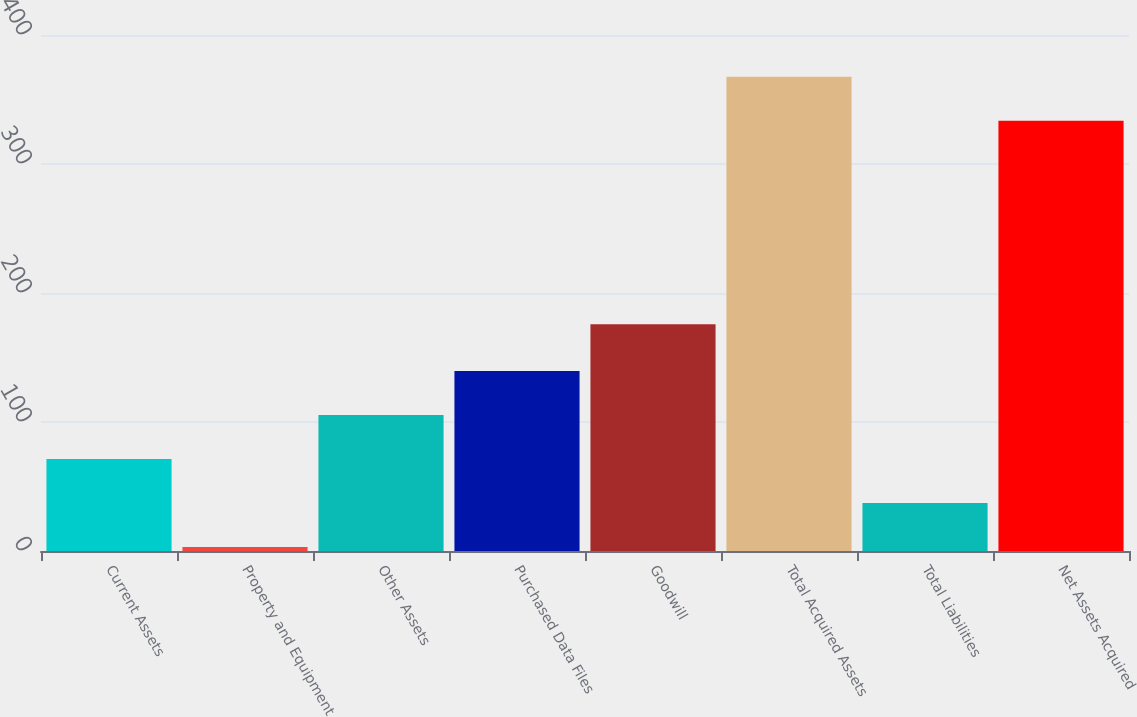Convert chart to OTSL. <chart><loc_0><loc_0><loc_500><loc_500><bar_chart><fcel>Current Assets<fcel>Property and Equipment<fcel>Other Assets<fcel>Purchased Data Files<fcel>Goodwill<fcel>Total Acquired Assets<fcel>Total Liabilities<fcel>Net Assets Acquired<nl><fcel>71.32<fcel>3.1<fcel>105.43<fcel>139.54<fcel>175.7<fcel>367.71<fcel>37.21<fcel>333.6<nl></chart> 